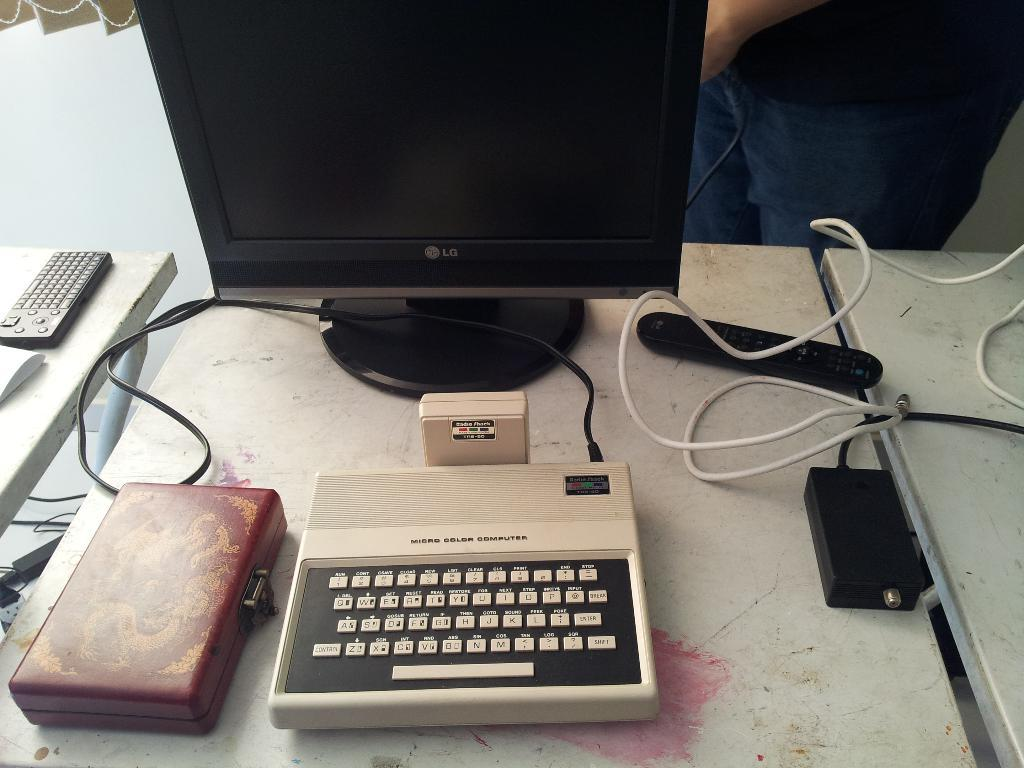<image>
Provide a brief description of the given image. A modern LG monitor is hooked to a very old radio shack computer. 